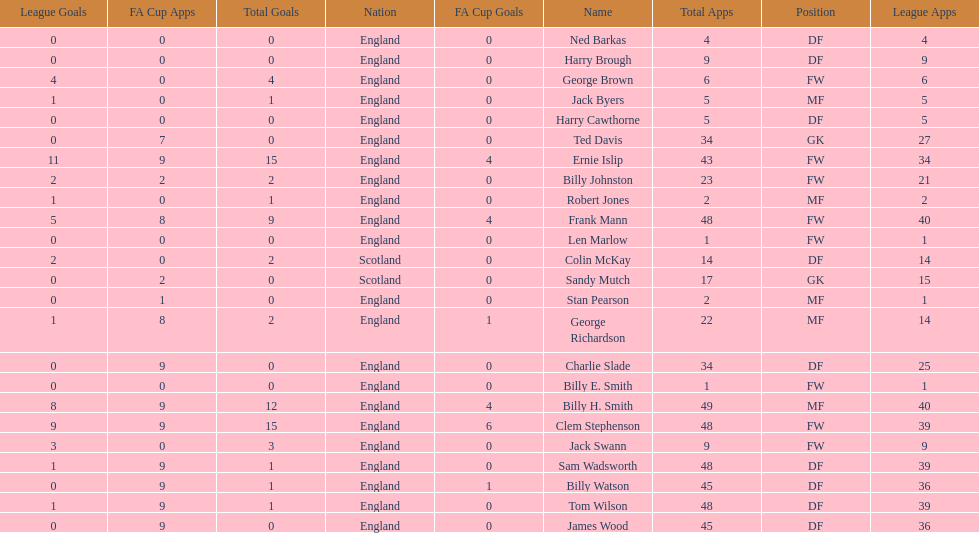Average number of goals scored by players from scotland 1. 